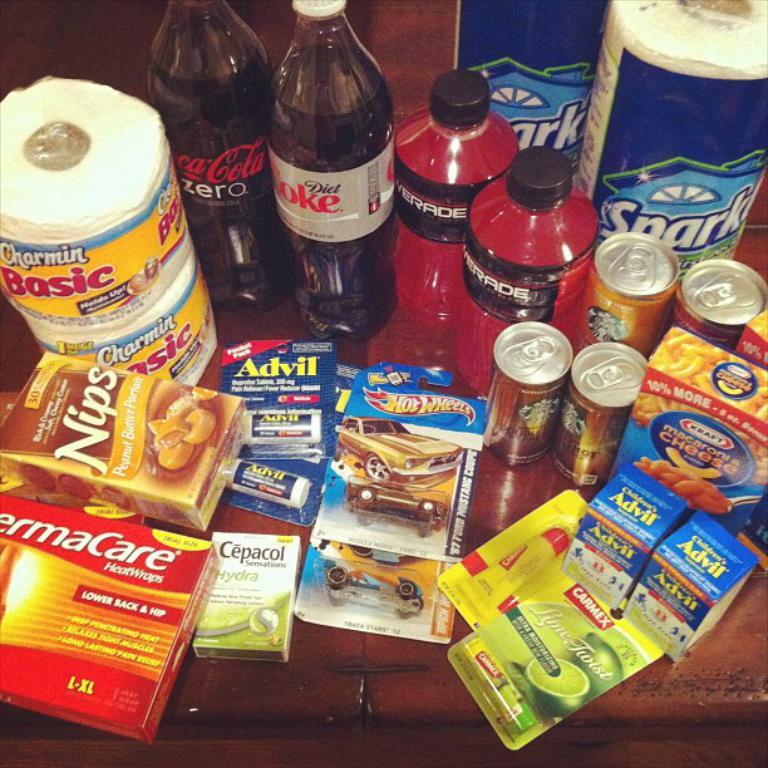<image>
Render a clear and concise summary of the photo. Advil, food, soda, powerade, and paper towels on a table 